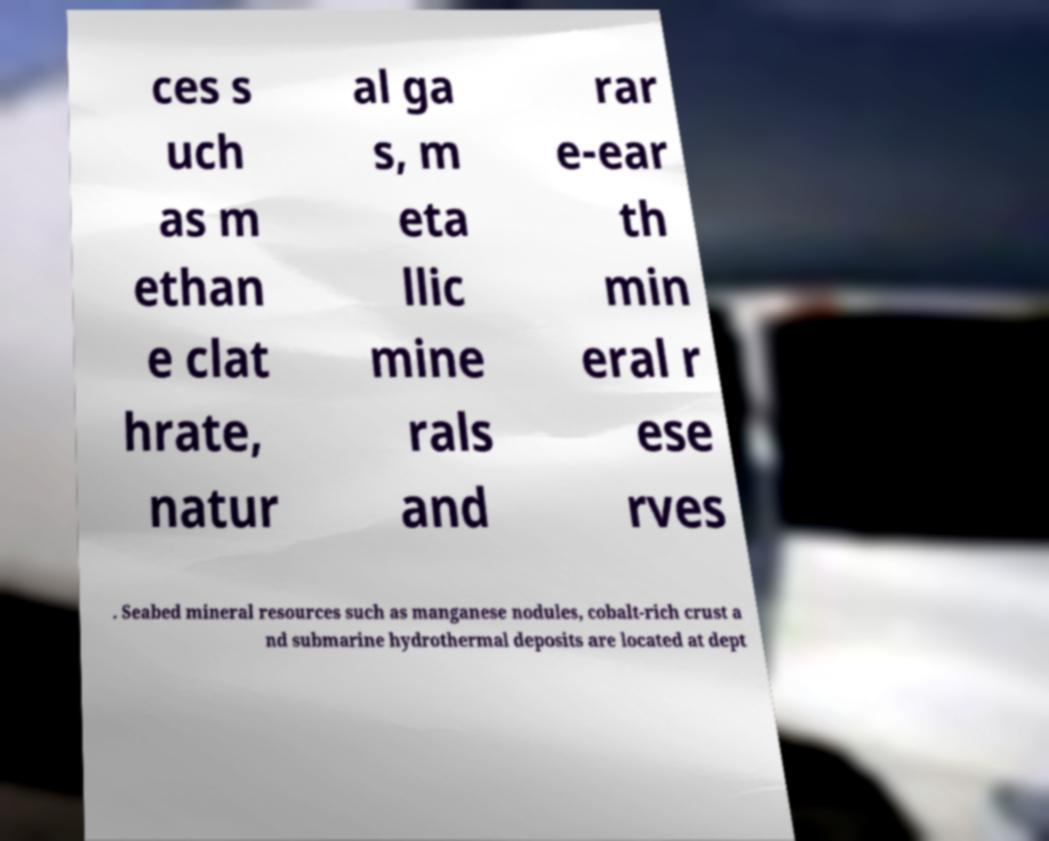What messages or text are displayed in this image? I need them in a readable, typed format. ces s uch as m ethan e clat hrate, natur al ga s, m eta llic mine rals and rar e-ear th min eral r ese rves . Seabed mineral resources such as manganese nodules, cobalt-rich crust a nd submarine hydrothermal deposits are located at dept 